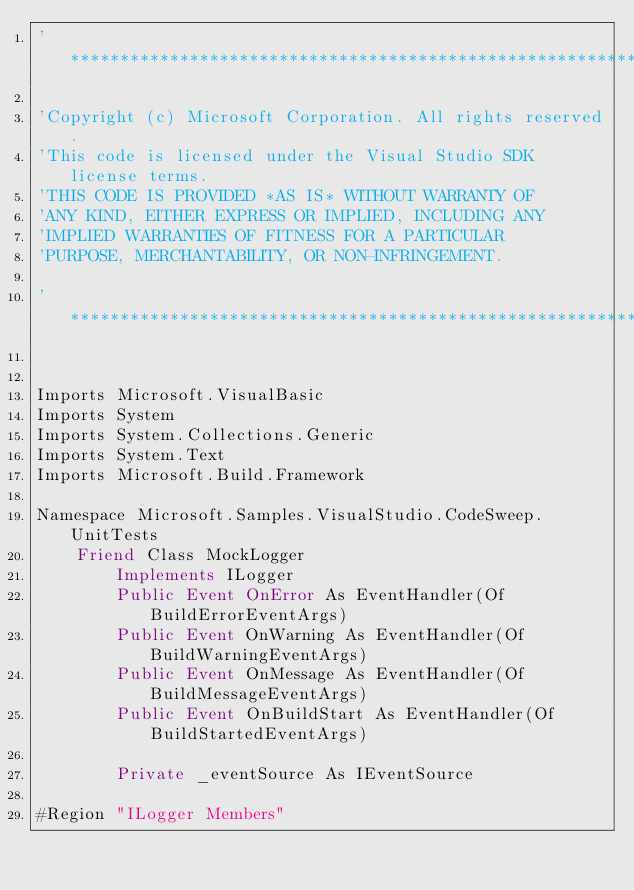<code> <loc_0><loc_0><loc_500><loc_500><_VisualBasic_>'**************************************************************************

'Copyright (c) Microsoft Corporation. All rights reserved.
'This code is licensed under the Visual Studio SDK license terms.
'THIS CODE IS PROVIDED *AS IS* WITHOUT WARRANTY OF
'ANY KIND, EITHER EXPRESS OR IMPLIED, INCLUDING ANY
'IMPLIED WARRANTIES OF FITNESS FOR A PARTICULAR
'PURPOSE, MERCHANTABILITY, OR NON-INFRINGEMENT.

'**************************************************************************


Imports Microsoft.VisualBasic
Imports System
Imports System.Collections.Generic
Imports System.Text
Imports Microsoft.Build.Framework

Namespace Microsoft.Samples.VisualStudio.CodeSweep.UnitTests
    Friend Class MockLogger
        Implements ILogger
        Public Event OnError As EventHandler(Of BuildErrorEventArgs)
        Public Event OnWarning As EventHandler(Of BuildWarningEventArgs)
        Public Event OnMessage As EventHandler(Of BuildMessageEventArgs)
        Public Event OnBuildStart As EventHandler(Of BuildStartedEventArgs)

        Private _eventSource As IEventSource

#Region "ILogger Members"
</code> 